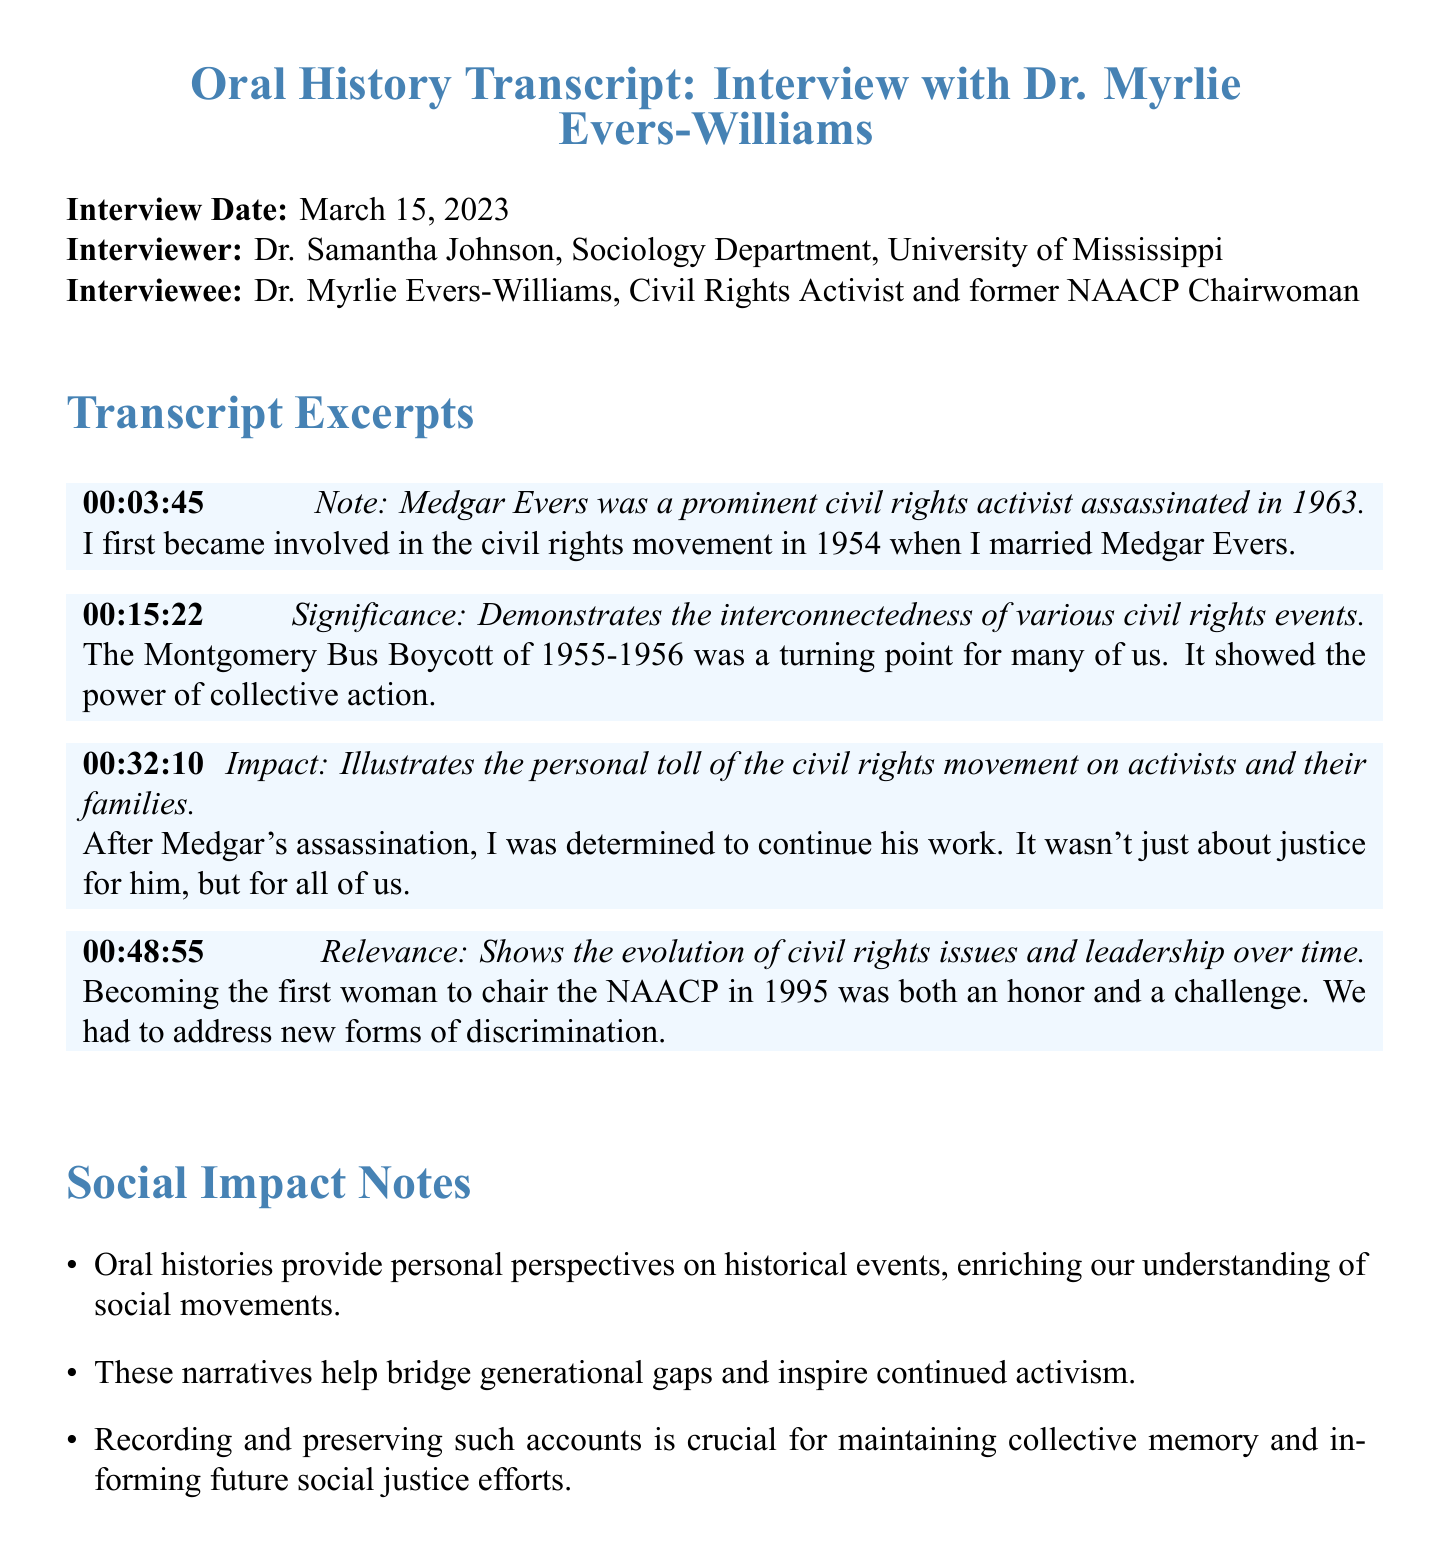What was the interview date? The interview date is explicitly stated in the document as March 15, 2023.
Answer: March 15, 2023 Who was the interviewer? The document lists Dr. Samantha Johnson as the interviewer in the introduction section.
Answer: Dr. Samantha Johnson What significant event is mentioned related to 1955-1956? The significance of the Montgomery Bus Boycott is mentioned as a turning point for activists.
Answer: Montgomery Bus Boycott What year did Dr. Myrlie Evers-Williams become chairwoman of the NAACP? The document specifies the year she became chairwoman as 1995.
Answer: 1995 What personal toll is discussed following Medgar Evers' assassination? The excerpt reflects on Dr. Myrlie Evers-Williams' determination to continue activism after her husband's death.
Answer: Determination Which civil rights leader is mentioned as having been assassinated in 1963? The document identifies Medgar Evers as the civil rights activist who was assassinated.
Answer: Medgar Evers What is the purpose of recording and preserving oral histories? The document states that recording such accounts is crucial for maintaining collective memory and informing future activism.
Answer: Maintaining collective memory How does the document categorize its sections? The sections are specifically organized into "Transcript Excerpts" and "Social Impact Notes."
Answer: Transcript Excerpts and Social Impact Notes 